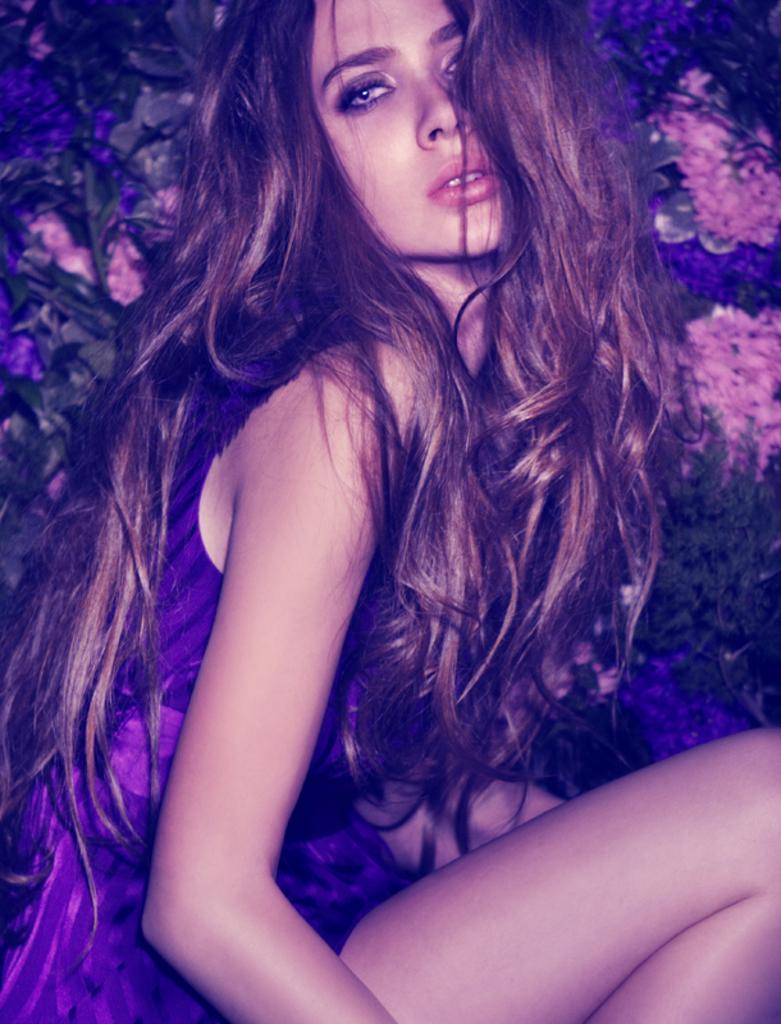Could you give a brief overview of what you see in this image? In this image we can see a women and in the background there are few flowers and leaves. 